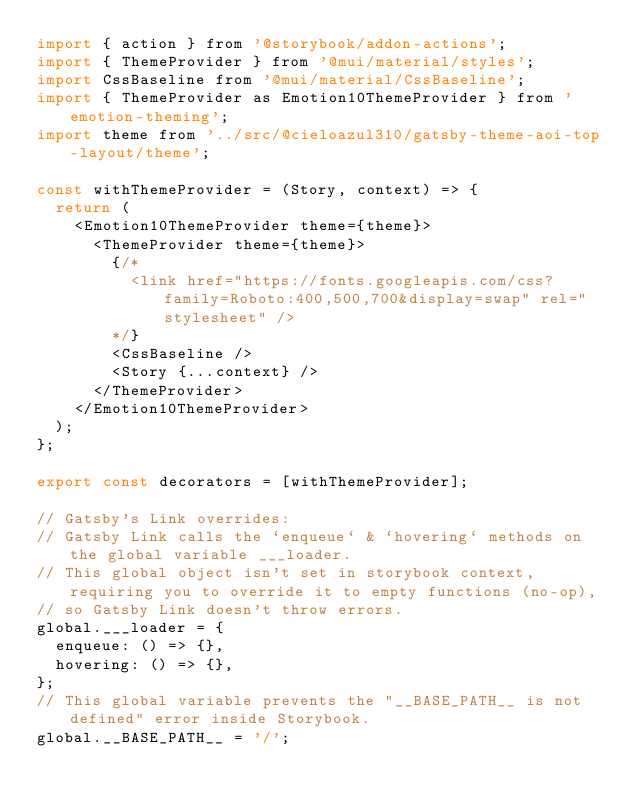Convert code to text. <code><loc_0><loc_0><loc_500><loc_500><_JavaScript_>import { action } from '@storybook/addon-actions';
import { ThemeProvider } from '@mui/material/styles';
import CssBaseline from '@mui/material/CssBaseline';
import { ThemeProvider as Emotion10ThemeProvider } from 'emotion-theming';
import theme from '../src/@cieloazul310/gatsby-theme-aoi-top-layout/theme';

const withThemeProvider = (Story, context) => {
  return (
    <Emotion10ThemeProvider theme={theme}>
      <ThemeProvider theme={theme}>
        {/*
          <link href="https://fonts.googleapis.com/css?family=Roboto:400,500,700&display=swap" rel="stylesheet" />
        */}
        <CssBaseline />
        <Story {...context} />
      </ThemeProvider>
    </Emotion10ThemeProvider>
  );
};

export const decorators = [withThemeProvider];

// Gatsby's Link overrides:
// Gatsby Link calls the `enqueue` & `hovering` methods on the global variable ___loader.
// This global object isn't set in storybook context, requiring you to override it to empty functions (no-op),
// so Gatsby Link doesn't throw errors.
global.___loader = {
  enqueue: () => {},
  hovering: () => {},
};
// This global variable prevents the "__BASE_PATH__ is not defined" error inside Storybook.
global.__BASE_PATH__ = '/';</code> 